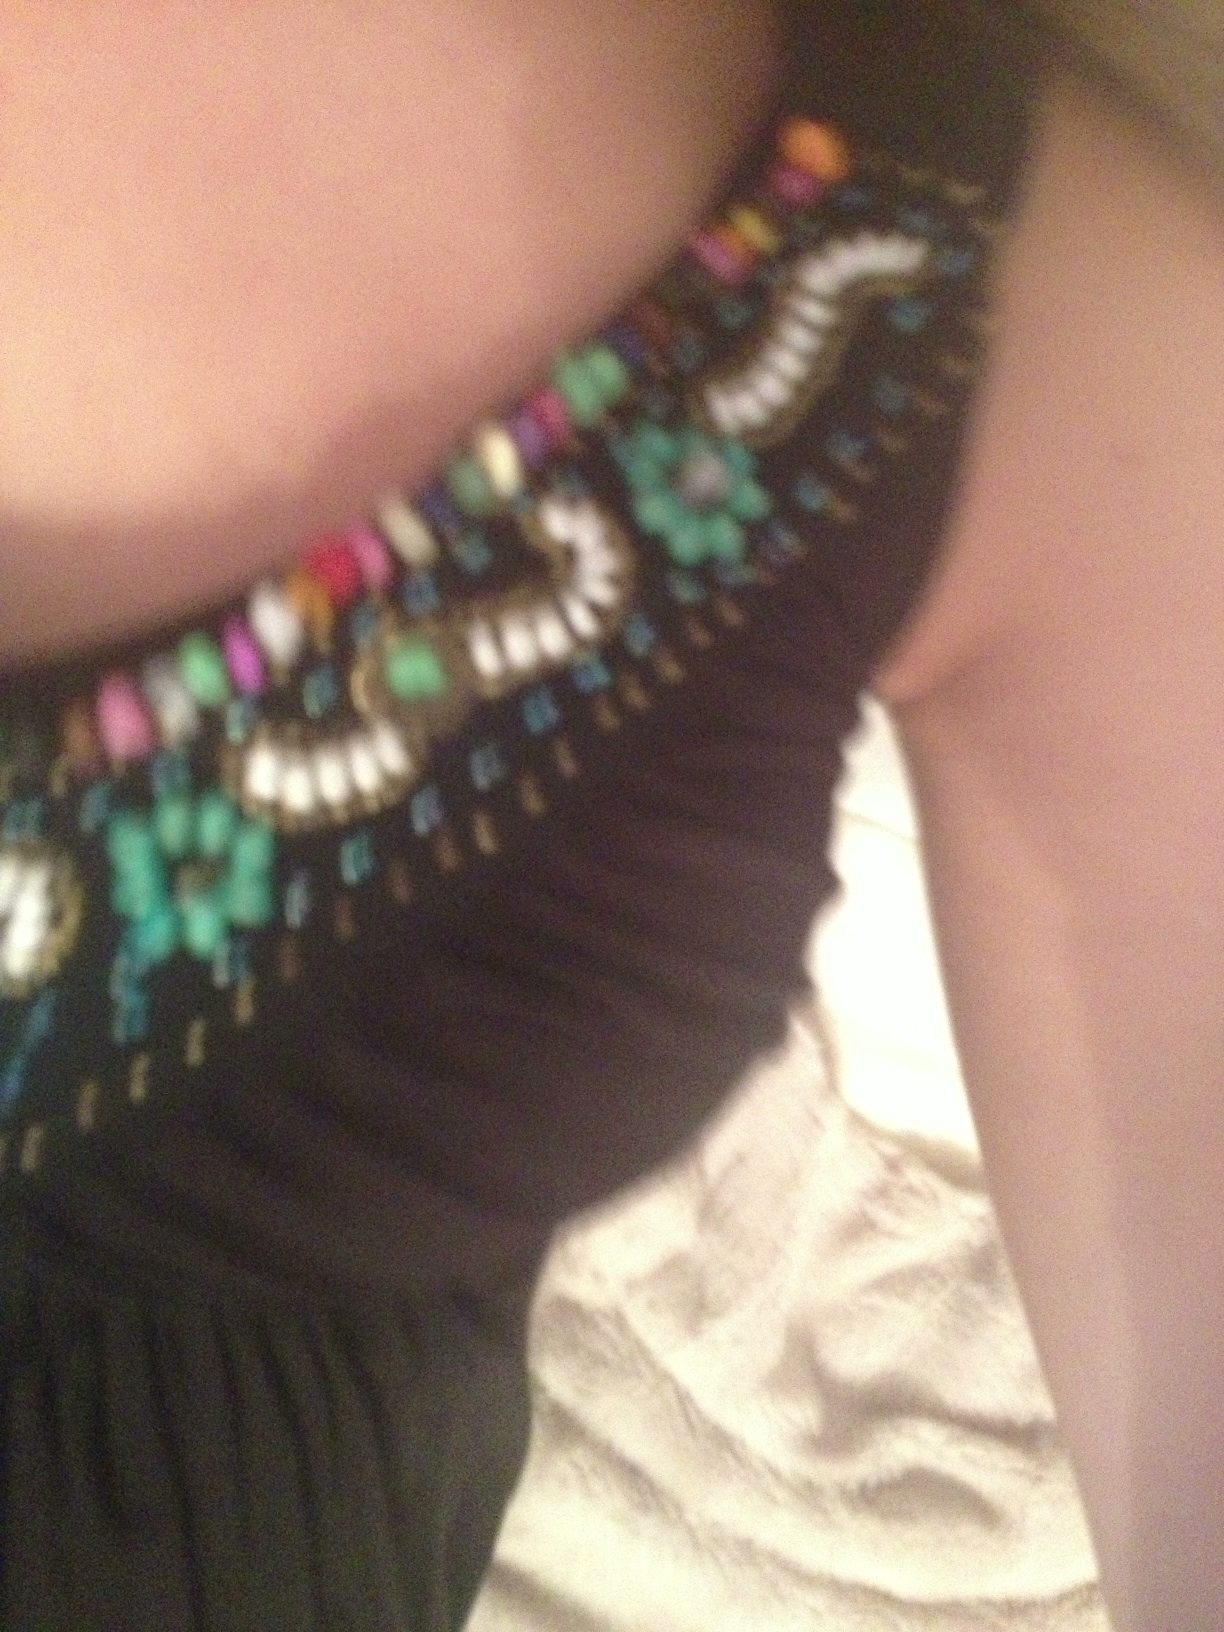Could you suggest appropriate footwear to go with this dress? Given the dress and its ornate neckline, a pair of elegant black or metallic heels would coordinate well. Choose a style with simple lines to avoid detracting from the dress's details, such as a classic stiletto or a sophisticated strappy sandal. 